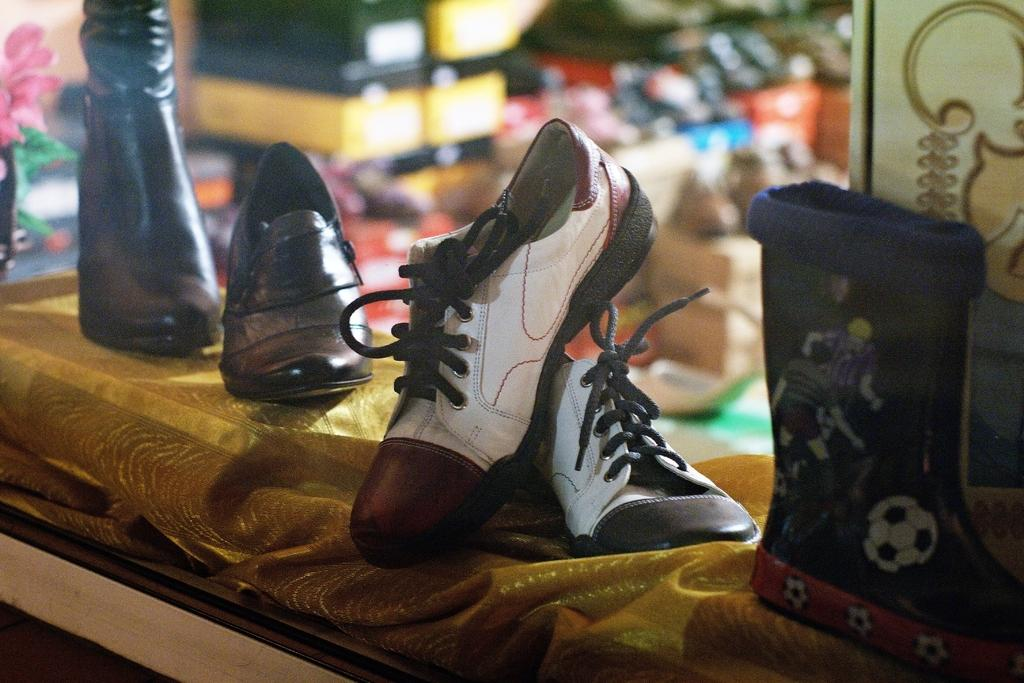What is the main subject of the image? The main subject of the image is a group of shoes. How are the shoes arranged in the image? The shoes are placed on a cloth. What can be seen in the background of the image? There are containers in the background of the image. Is there any other object or element in the image besides the shoes and containers? Yes, there is a flower in the image. What type of vegetable is being used as a decoration in the image? There is no vegetable present in the image; it features a group of shoes, containers, and a flower. Can you tell me how many lizards are crawling on the shoes in the image? There are no lizards present in the image; it only contains shoes, a cloth, containers, and a flower. 